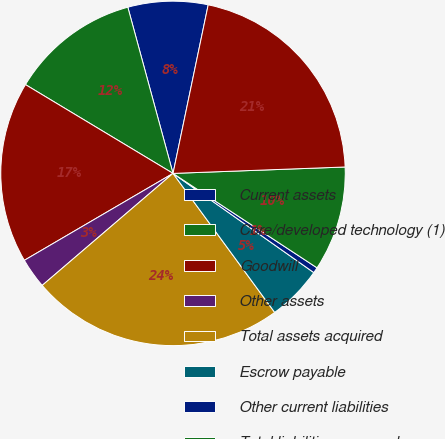Convert chart to OTSL. <chart><loc_0><loc_0><loc_500><loc_500><pie_chart><fcel>Current assets<fcel>Core/developed technology (1)<fcel>Goodwill<fcel>Other assets<fcel>Total assets acquired<fcel>Escrow payable<fcel>Other current liabilities<fcel>Total liabilities assumed<fcel>Net assets acquired<nl><fcel>7.5%<fcel>12.15%<fcel>17.04%<fcel>2.85%<fcel>23.78%<fcel>5.18%<fcel>0.53%<fcel>9.83%<fcel>21.13%<nl></chart> 